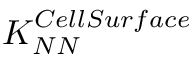<formula> <loc_0><loc_0><loc_500><loc_500>K _ { N N } ^ { C e l l S u r f a c e }</formula> 